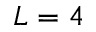<formula> <loc_0><loc_0><loc_500><loc_500>L = 4</formula> 